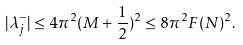Convert formula to latex. <formula><loc_0><loc_0><loc_500><loc_500>| \lambda ^ { - } _ { j } | \leq 4 \pi ^ { 2 } ( M + \frac { 1 } { 2 } ) ^ { 2 } \leq 8 \pi ^ { 2 } F ( N ) ^ { 2 } .</formula> 